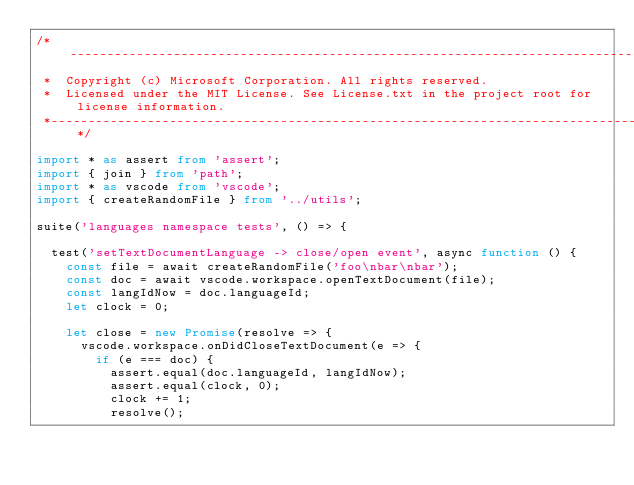<code> <loc_0><loc_0><loc_500><loc_500><_TypeScript_>/*---------------------------------------------------------------------------------------------
 *  Copyright (c) Microsoft Corporation. All rights reserved.
 *  Licensed under the MIT License. See License.txt in the project root for license information.
 *--------------------------------------------------------------------------------------------*/

import * as assert from 'assert';
import { join } from 'path';
import * as vscode from 'vscode';
import { createRandomFile } from '../utils';

suite('languages namespace tests', () => {

	test('setTextDocumentLanguage -> close/open event', async function () {
		const file = await createRandomFile('foo\nbar\nbar');
		const doc = await vscode.workspace.openTextDocument(file);
		const langIdNow = doc.languageId;
		let clock = 0;

		let close = new Promise(resolve => {
			vscode.workspace.onDidCloseTextDocument(e => {
				if (e === doc) {
					assert.equal(doc.languageId, langIdNow);
					assert.equal(clock, 0);
					clock += 1;
					resolve();</code> 